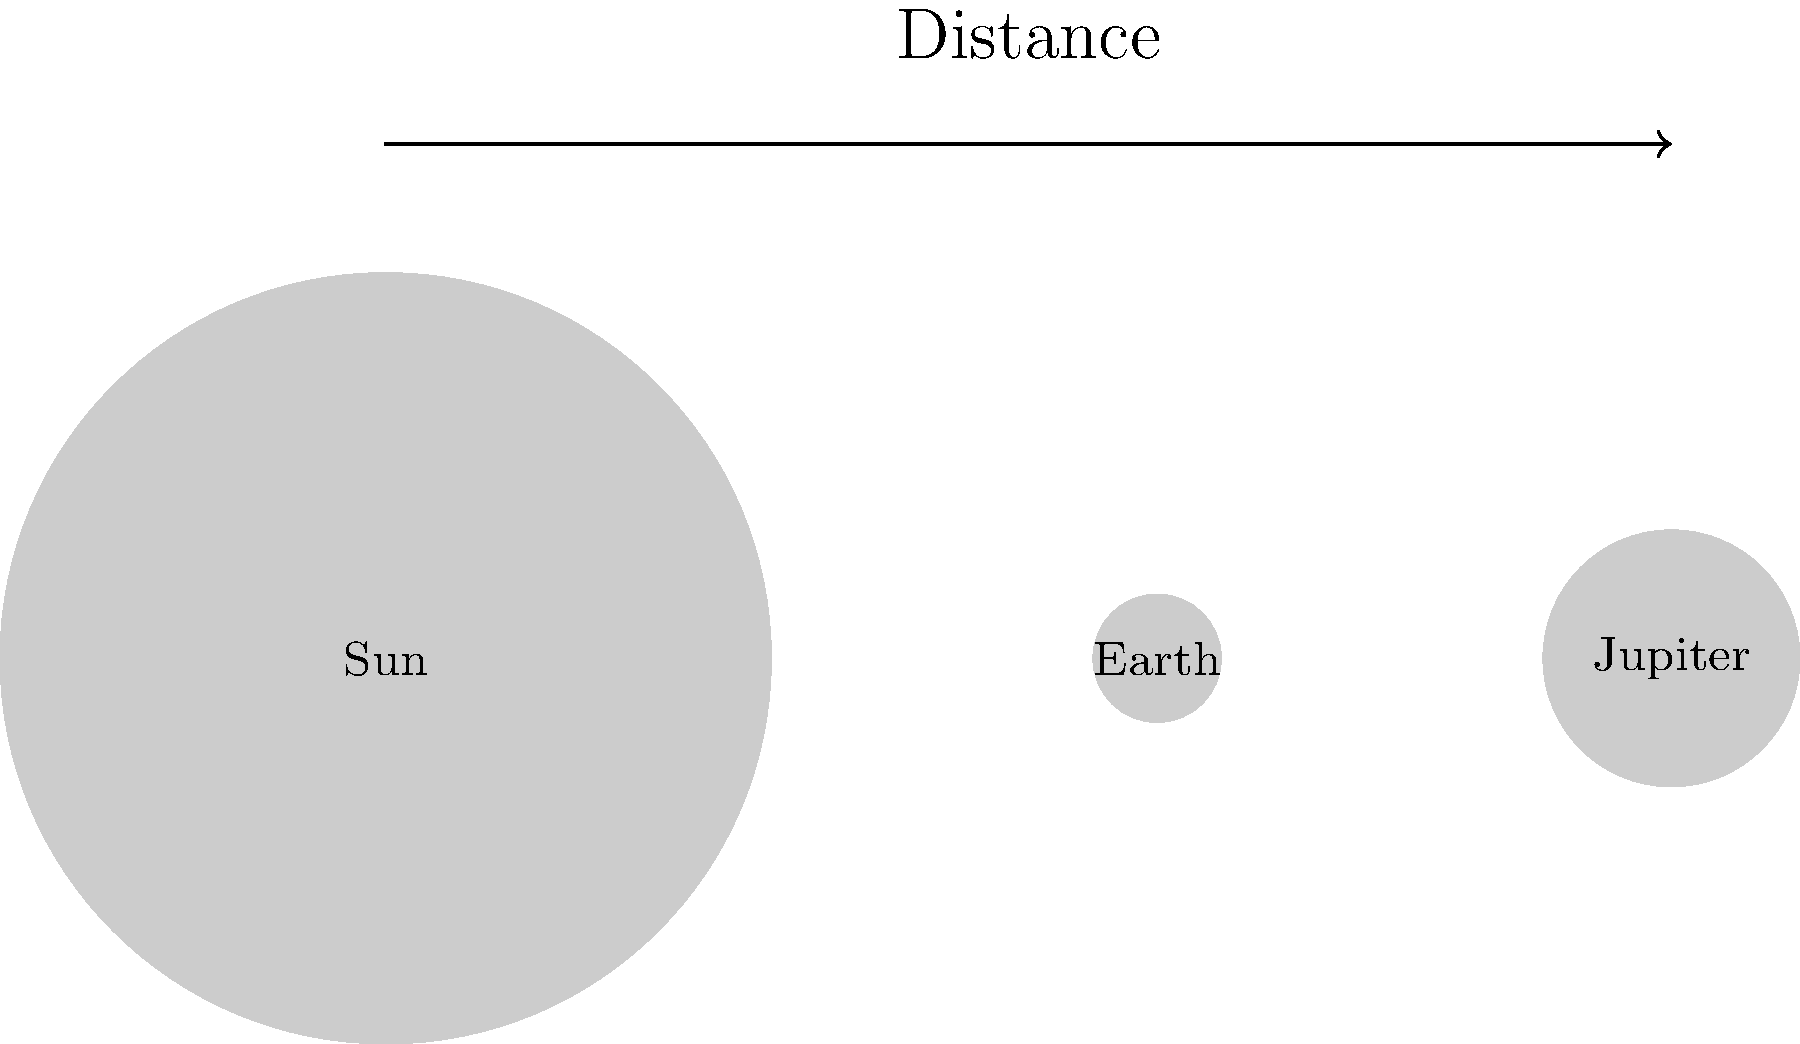As a radio host promoting Cut Out Cancer events, you often use space analogies to inspire your audience. If the Sun were scaled down to the size of a basketball, approximately how far away would Earth be in this model? Let's approach this step-by-step:

1. First, we need to know the actual sizes and distances:
   - Sun's diameter: approximately 1,391,000 km
   - Earth's distance from Sun: approximately 149,600,000 km

2. Now, let's consider the scale:
   - A typical basketball has a diameter of about 24 cm (0.24 m)

3. We need to find the scale factor:
   $\text{Scale factor} = \frac{\text{Basketball diameter}}{\text{Sun's diameter}} = \frac{0.24 \text{ m}}{1,391,000,000 \text{ m}} \approx 1.72 \times 10^{-10}$

4. Now, we can apply this scale factor to Earth's distance:
   $\text{Scaled Earth distance} = 149,600,000,000 \text{ m} \times 1.72 \times 10^{-10} \approx 25.7 \text{ m}$

5. Converting to a more relatable unit:
   $25.7 \text{ m} \approx 84 \text{ feet}$

Therefore, if the Sun were scaled down to the size of a basketball, Earth would be about 26 meters or 84 feet away.
Answer: Approximately 26 meters (84 feet) 